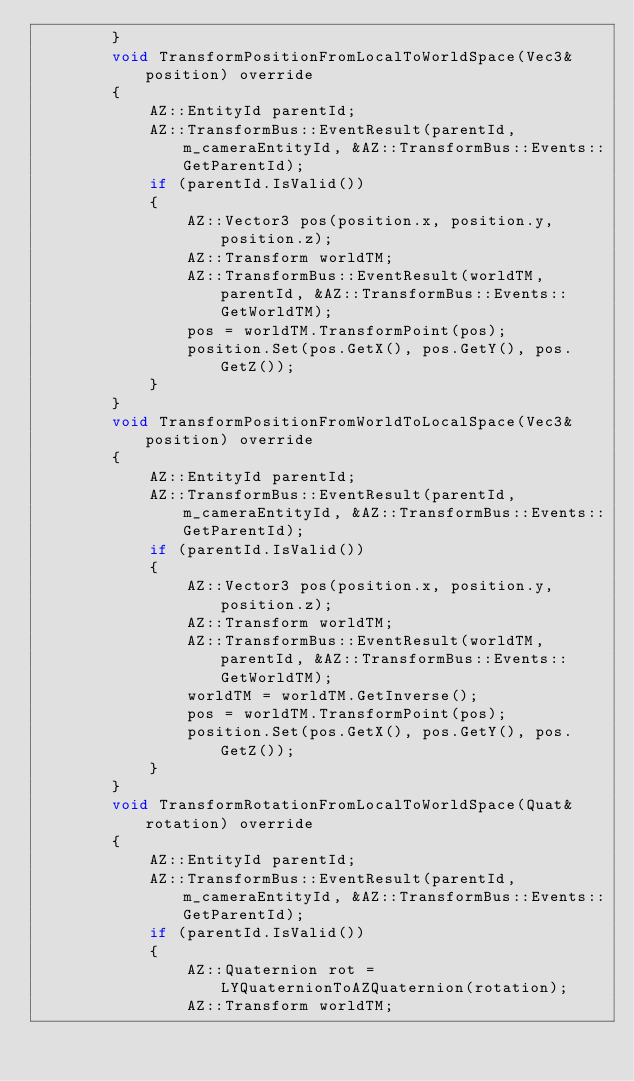<code> <loc_0><loc_0><loc_500><loc_500><_C++_>        }
        void TransformPositionFromLocalToWorldSpace(Vec3& position) override
        {
            AZ::EntityId parentId;
            AZ::TransformBus::EventResult(parentId, m_cameraEntityId, &AZ::TransformBus::Events::GetParentId);
            if (parentId.IsValid())
            {
                AZ::Vector3 pos(position.x, position.y, position.z);
                AZ::Transform worldTM;
                AZ::TransformBus::EventResult(worldTM, parentId, &AZ::TransformBus::Events::GetWorldTM);
                pos = worldTM.TransformPoint(pos);
                position.Set(pos.GetX(), pos.GetY(), pos.GetZ());
            }
        }
        void TransformPositionFromWorldToLocalSpace(Vec3& position) override
        {
            AZ::EntityId parentId;
            AZ::TransformBus::EventResult(parentId, m_cameraEntityId, &AZ::TransformBus::Events::GetParentId);
            if (parentId.IsValid())
            {
                AZ::Vector3 pos(position.x, position.y, position.z);
                AZ::Transform worldTM;
                AZ::TransformBus::EventResult(worldTM, parentId, &AZ::TransformBus::Events::GetWorldTM);
                worldTM = worldTM.GetInverse();
                pos = worldTM.TransformPoint(pos);
                position.Set(pos.GetX(), pos.GetY(), pos.GetZ());
            }
        }
        void TransformRotationFromLocalToWorldSpace(Quat& rotation) override
        {
            AZ::EntityId parentId;
            AZ::TransformBus::EventResult(parentId, m_cameraEntityId, &AZ::TransformBus::Events::GetParentId);
            if (parentId.IsValid())
            {
                AZ::Quaternion rot = LYQuaternionToAZQuaternion(rotation);
                AZ::Transform worldTM;</code> 